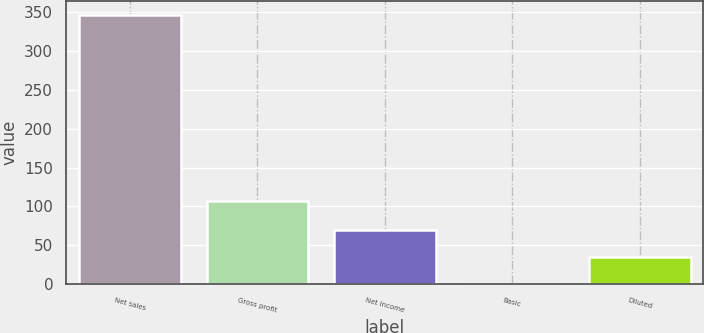Convert chart. <chart><loc_0><loc_0><loc_500><loc_500><bar_chart><fcel>Net sales<fcel>Gross profit<fcel>Net income<fcel>Basic<fcel>Diluted<nl><fcel>346.8<fcel>106.4<fcel>69.66<fcel>0.38<fcel>35.02<nl></chart> 